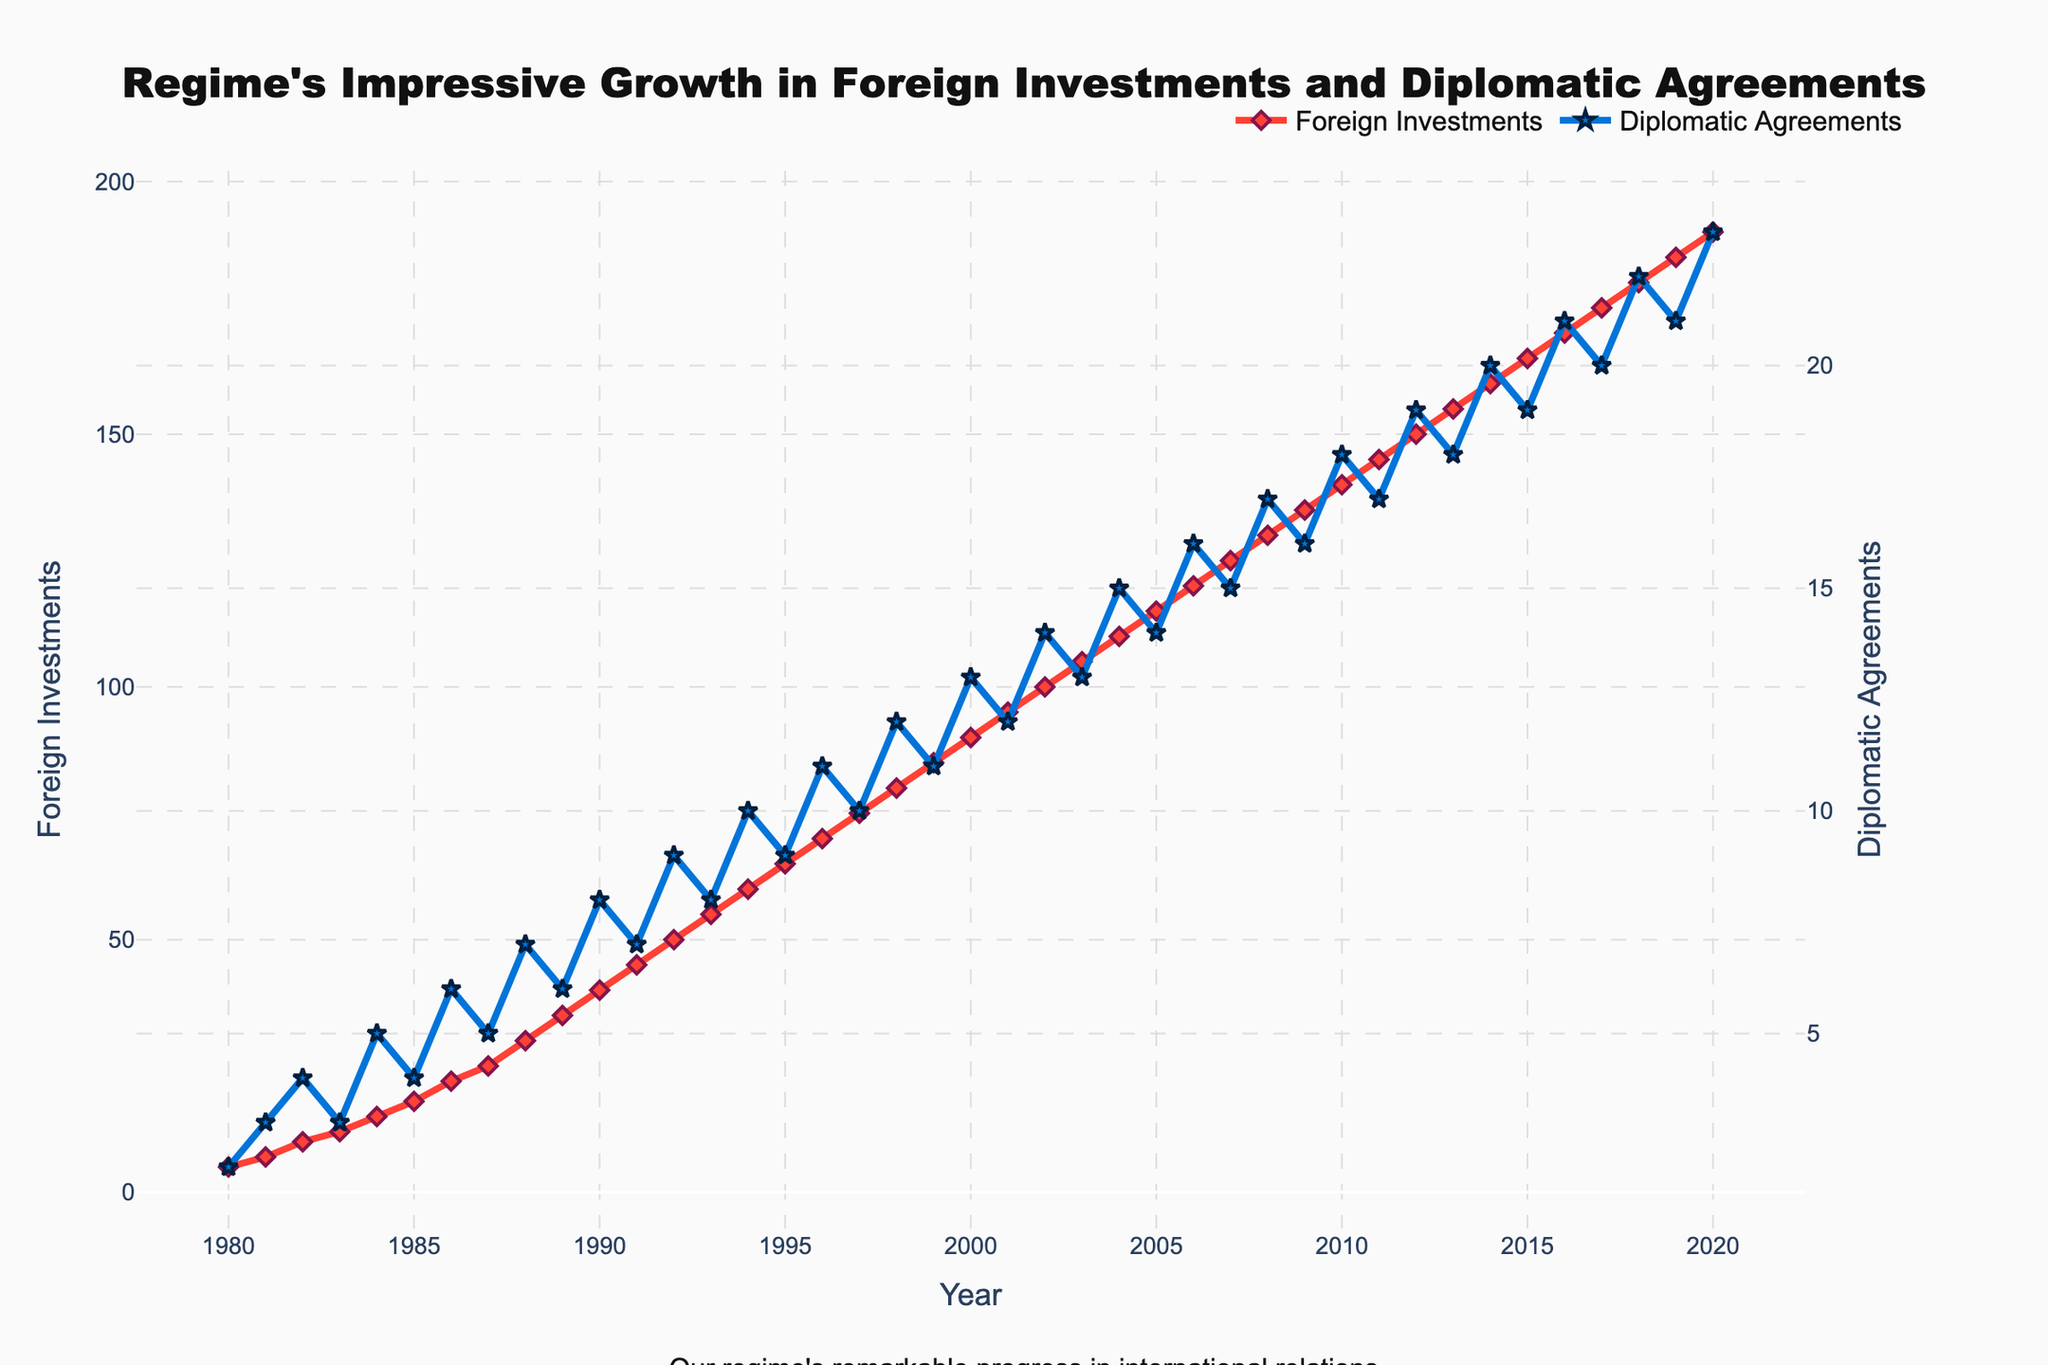How many more foreign investments were there in 2020 compared to 1980? Subtract the number of foreign investments in 1980 (5) from the number in 2020 (190): 190 - 5 = 185
Answer: 185 In which year did the number of diplomatic agreements first reach double digits? Identify the first year in the 'Diplomatic Agreements' series where the value is 10 or greater. The value reaches 10 in 1994.
Answer: 1994 What’s the average annual number of foreign investments between 2000 and 2010? Sum the number of foreign investments from 2000 to 2010: 90+95+100+105+110+115+120+125+130+135+140 = 1265. There are 11 years, so divide by 11: 1265 / 11 = 115
Answer: 115 During which decade did the number of foreign investments increase the most? Calculate the difference in foreign investments at the beginning and end of each decade: 
1980s: 35 - 5 = 30; 1990s: 85 - 40 = 45; 2000s: 135 - 90 = 45; 2010s: 185 - 140 = 45. 
So, the greatest increase (45) occurred in the 1990s, 2000s, and 2010s.
Answer: 1990s, 2000s, and 2010s What are the colors used for the lines representing foreign investments and diplomatic agreements? The visual attributes show the line for foreign investments in red and the line for diplomatic agreements in blue.
Answer: Red for foreign investments, blue for diplomatic agreements By how much did the number of diplomatic agreements increase between 1990 and 2000? Subtract the number of diplomatic agreements in 1990 (8) from the number in 2000 (13): 13 - 8 = 5
Answer: 5 How does the trend in foreign investments compare to the trend in diplomatic agreements over the years? Both trends show consistent growth. However, the rate of increase in foreign investments is higher than that of diplomatic agreements throughout the years.
Answer: Foreign investments increased faster than diplomatic agreements What was the percentage increase in foreign investments from 1980 to 2020? Calculate the increase: 190 - 5 = 185. Then, divide by the initial value and multiply by 100: (185 / 5) * 100 = 3700%
Answer: 3700% In what year do the foreign investments first reach 100? Identify the year in the 'Foreign Investments' series where the value first reaches 100. This occurs in 2002.
Answer: 2002 